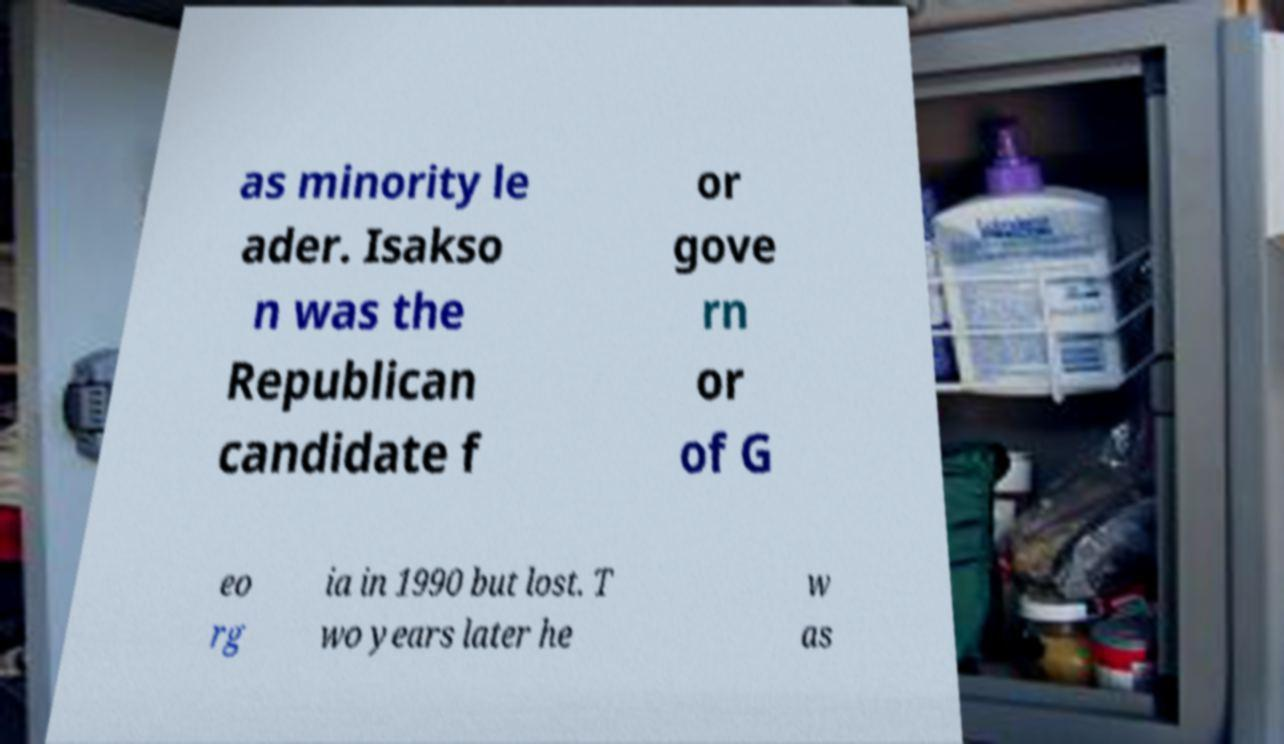There's text embedded in this image that I need extracted. Can you transcribe it verbatim? as minority le ader. Isakso n was the Republican candidate f or gove rn or of G eo rg ia in 1990 but lost. T wo years later he w as 